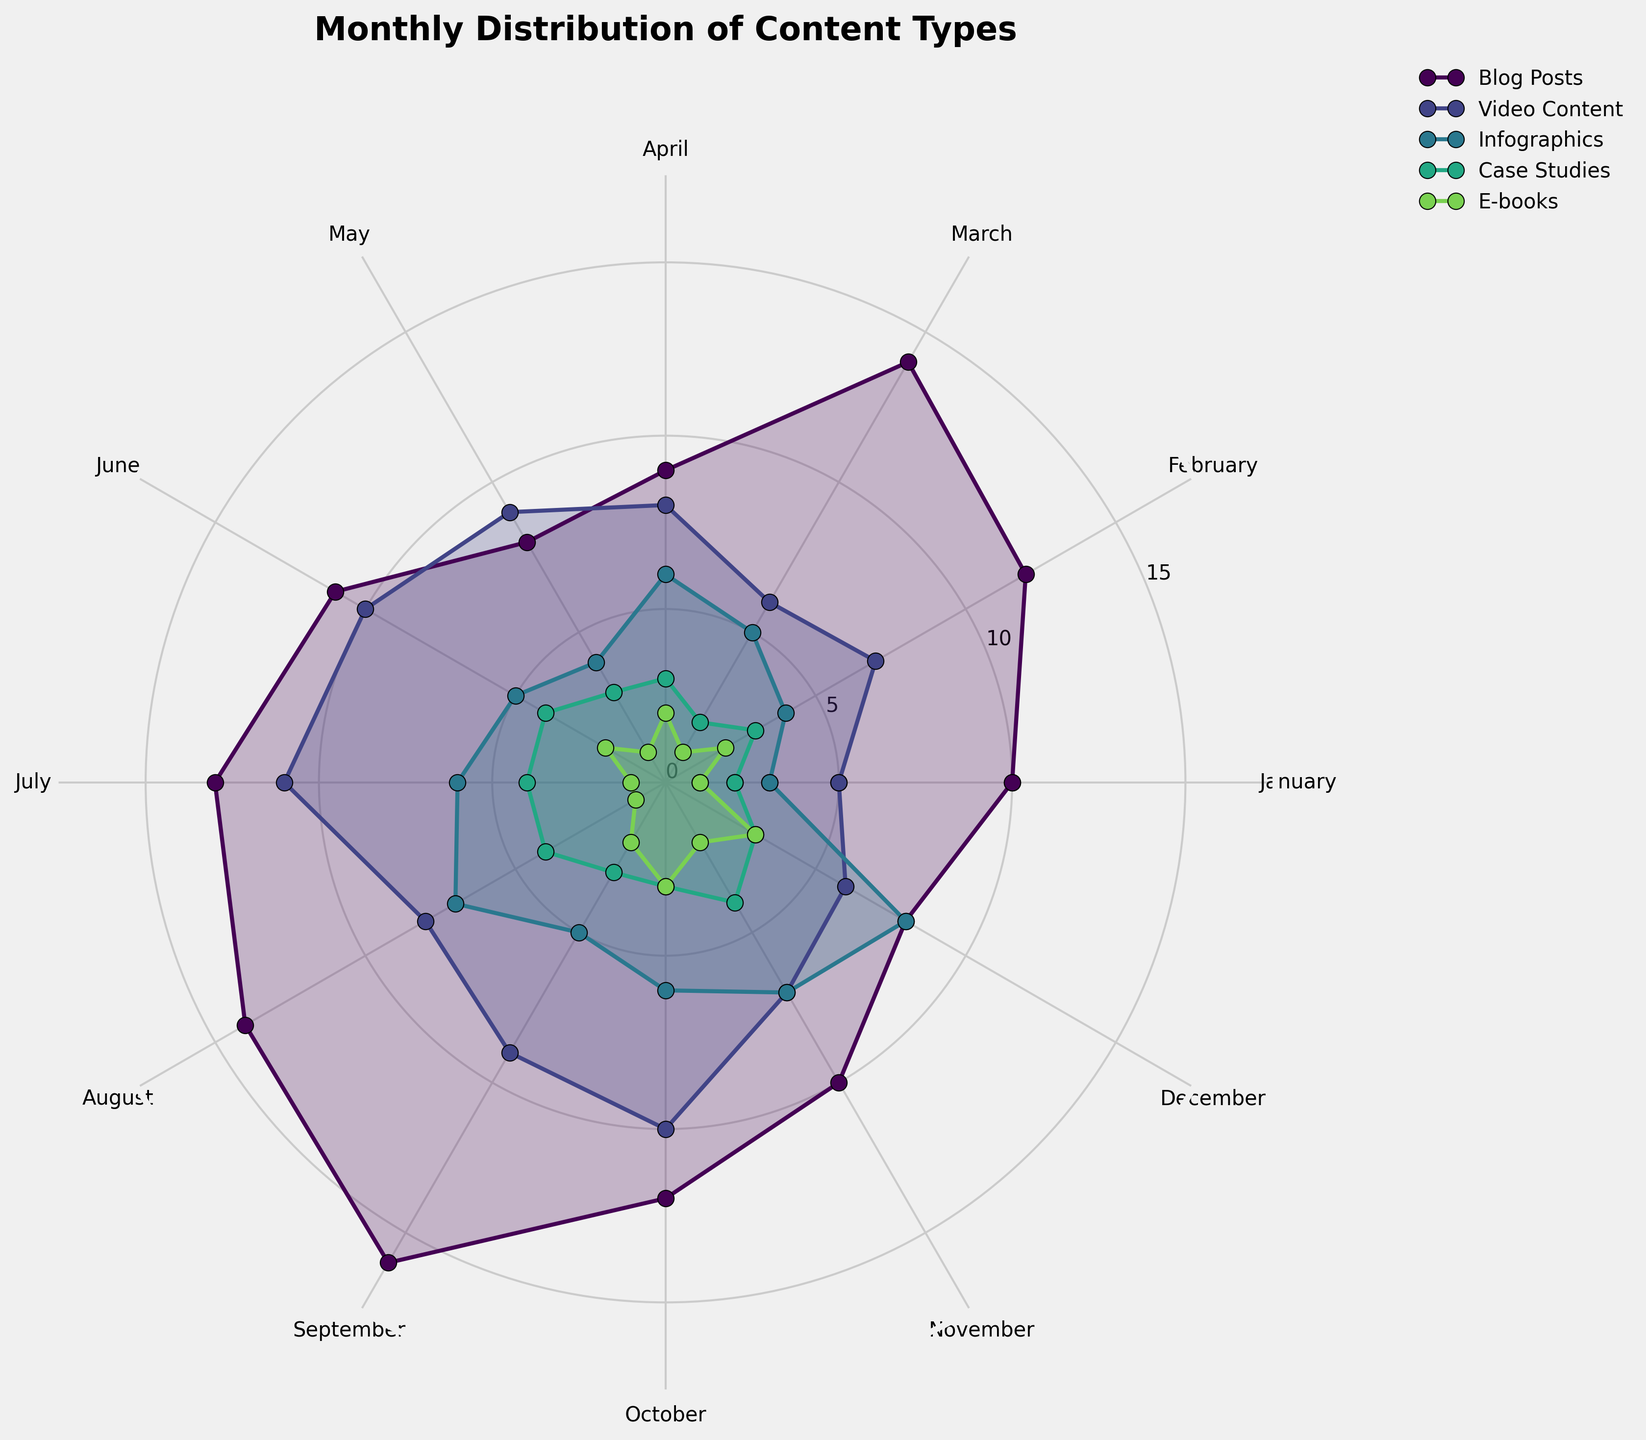What's the title of this figure? The title is displayed at the top of the plot, which reads 'Monthly Distribution of Content Types'.
Answer: Monthly Distribution of Content Types Which content type is represented with the largest area in December? In a polar area chart, the larger areas correspond to higher values. By looking at December, the Blog Posts segment holds the largest area compared to other content types.
Answer: Blog Posts How does the amount of Video Content change from January to July? To determine the change, observe the value for Video Content in January (5), and in July (11). There's a progression of increasing values over these months.
Answer: It increases Which months have the highest number of Infographics published? Observe where the Infographics segment has its highest points on the plot. The peak points in the plot for Infographics are in November and December.
Answer: November and December What is the general trend for E-books over the year? Evaluate the trend by following the line/area representing E-books throughout the year. The chart segment starts low, increases mid-year, dips again, and rises toward the end of the year.
Answer: Fluctuates with a rise at year-end In June, which content type had the lowest publication count? By examining the chart and comparing the areas for June, E-books exhibit the smallest area, hence the lowest count.
Answer: E-books How many more Blog Posts were published in September compared to February? Identify the Blog Posts values for September (16) and February (12), then subtract the February value from the September value to find the difference.
Answer: 4 more During which month did Case Studies see an increase in publication compared to the previous month? Look at successive months' values for Case Studies: one noticeable increase is from June (4) to July (4).
Answer: June Across all categories, which month has the overall peak content publication? By comparing the clustered heights and widths of the segments, September stands out as having the highest publication counts across most categories.
Answer: September Which category shows a steady and consistent increase throughout the year? Assessing each category's progression, Infographics display a steady and consistent increase from January to December.
Answer: Infographics 